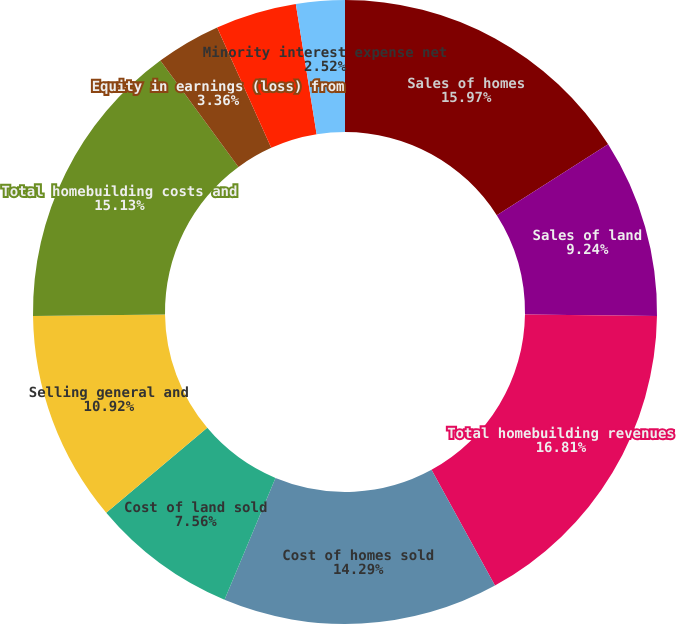Convert chart to OTSL. <chart><loc_0><loc_0><loc_500><loc_500><pie_chart><fcel>Sales of homes<fcel>Sales of land<fcel>Total homebuilding revenues<fcel>Cost of homes sold<fcel>Cost of land sold<fcel>Selling general and<fcel>Total homebuilding costs and<fcel>Equity in earnings (loss) from<fcel>Management fees and other<fcel>Minority interest expense net<nl><fcel>15.97%<fcel>9.24%<fcel>16.81%<fcel>14.29%<fcel>7.56%<fcel>10.92%<fcel>15.13%<fcel>3.36%<fcel>4.2%<fcel>2.52%<nl></chart> 